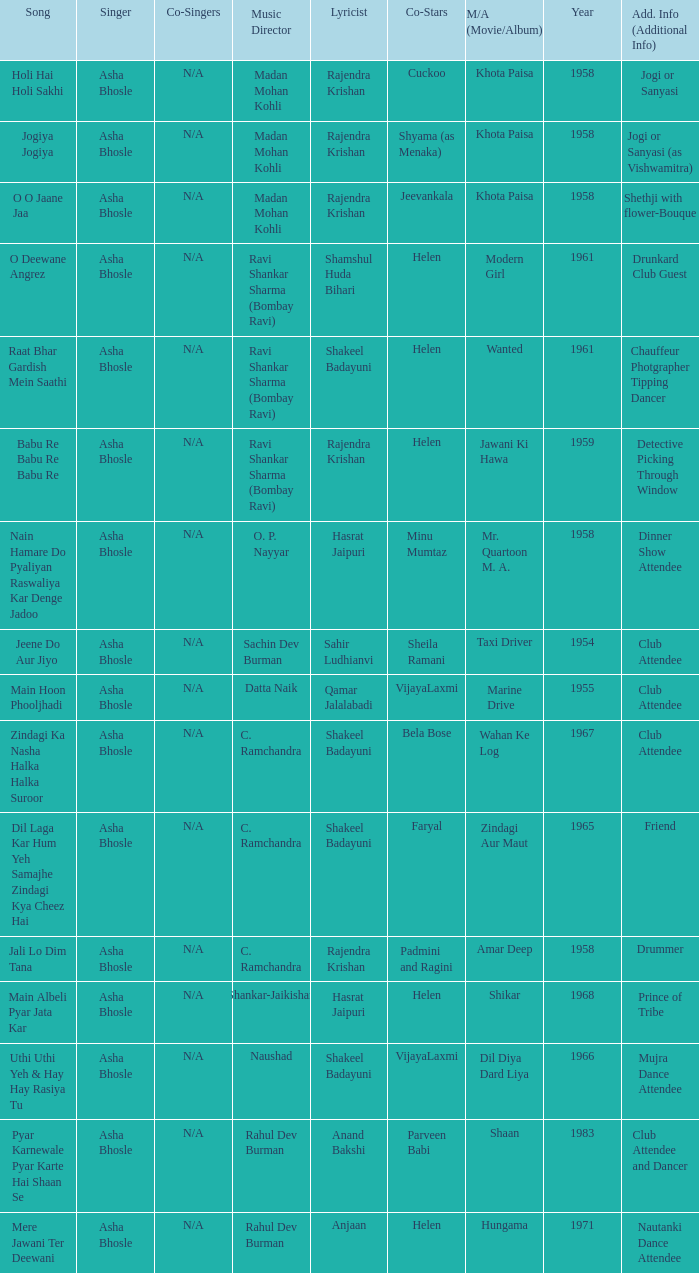Who wrote the lyrics when Jeevankala co-starred? Rajendra Krishan. Could you help me parse every detail presented in this table? {'header': ['Song', 'Singer', 'Co-Singers', 'Music Director', 'Lyricist', 'Co-Stars', 'M/A (Movie/Album)', 'Year', 'Add. Info (Additional Info)'], 'rows': [['Holi Hai Holi Sakhi', 'Asha Bhosle', 'N/A', 'Madan Mohan Kohli', 'Rajendra Krishan', 'Cuckoo', 'Khota Paisa', '1958', 'Jogi or Sanyasi'], ['Jogiya Jogiya', 'Asha Bhosle', 'N/A', 'Madan Mohan Kohli', 'Rajendra Krishan', 'Shyama (as Menaka)', 'Khota Paisa', '1958', 'Jogi or Sanyasi (as Vishwamitra)'], ['O O Jaane Jaa', 'Asha Bhosle', 'N/A', 'Madan Mohan Kohli', 'Rajendra Krishan', 'Jeevankala', 'Khota Paisa', '1958', 'Shethji with flower-Bouque'], ['O Deewane Angrez', 'Asha Bhosle', 'N/A', 'Ravi Shankar Sharma (Bombay Ravi)', 'Shamshul Huda Bihari', 'Helen', 'Modern Girl', '1961', 'Drunkard Club Guest'], ['Raat Bhar Gardish Mein Saathi', 'Asha Bhosle', 'N/A', 'Ravi Shankar Sharma (Bombay Ravi)', 'Shakeel Badayuni', 'Helen', 'Wanted', '1961', 'Chauffeur Photgrapher Tipping Dancer'], ['Babu Re Babu Re Babu Re', 'Asha Bhosle', 'N/A', 'Ravi Shankar Sharma (Bombay Ravi)', 'Rajendra Krishan', 'Helen', 'Jawani Ki Hawa', '1959', 'Detective Picking Through Window'], ['Nain Hamare Do Pyaliyan Raswaliya Kar Denge Jadoo', 'Asha Bhosle', 'N/A', 'O. P. Nayyar', 'Hasrat Jaipuri', 'Minu Mumtaz', 'Mr. Quartoon M. A.', '1958', 'Dinner Show Attendee'], ['Jeene Do Aur Jiyo', 'Asha Bhosle', 'N/A', 'Sachin Dev Burman', 'Sahir Ludhianvi', 'Sheila Ramani', 'Taxi Driver', '1954', 'Club Attendee'], ['Main Hoon Phooljhadi', 'Asha Bhosle', 'N/A', 'Datta Naik', 'Qamar Jalalabadi', 'VijayaLaxmi', 'Marine Drive', '1955', 'Club Attendee'], ['Zindagi Ka Nasha Halka Halka Suroor', 'Asha Bhosle', 'N/A', 'C. Ramchandra', 'Shakeel Badayuni', 'Bela Bose', 'Wahan Ke Log', '1967', 'Club Attendee'], ['Dil Laga Kar Hum Yeh Samajhe Zindagi Kya Cheez Hai', 'Asha Bhosle', 'N/A', 'C. Ramchandra', 'Shakeel Badayuni', 'Faryal', 'Zindagi Aur Maut', '1965', 'Friend'], ['Jali Lo Dim Tana', 'Asha Bhosle', 'N/A', 'C. Ramchandra', 'Rajendra Krishan', 'Padmini and Ragini', 'Amar Deep', '1958', 'Drummer'], ['Main Albeli Pyar Jata Kar', 'Asha Bhosle', 'N/A', 'Shankar-Jaikishan', 'Hasrat Jaipuri', 'Helen', 'Shikar', '1968', 'Prince of Tribe'], ['Uthi Uthi Yeh & Hay Hay Rasiya Tu', 'Asha Bhosle', 'N/A', 'Naushad', 'Shakeel Badayuni', 'VijayaLaxmi', 'Dil Diya Dard Liya', '1966', 'Mujra Dance Attendee'], ['Pyar Karnewale Pyar Karte Hai Shaan Se', 'Asha Bhosle', 'N/A', 'Rahul Dev Burman', 'Anand Bakshi', 'Parveen Babi', 'Shaan', '1983', 'Club Attendee and Dancer'], ['Mere Jawani Ter Deewani', 'Asha Bhosle', 'N/A', 'Rahul Dev Burman', 'Anjaan', 'Helen', 'Hungama', '1971', 'Nautanki Dance Attendee']]} 